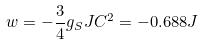Convert formula to latex. <formula><loc_0><loc_0><loc_500><loc_500>w = - \frac { 3 } { 4 } g _ { S } J C ^ { 2 } = - 0 . 6 8 8 J</formula> 